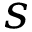<formula> <loc_0><loc_0><loc_500><loc_500>s</formula> 